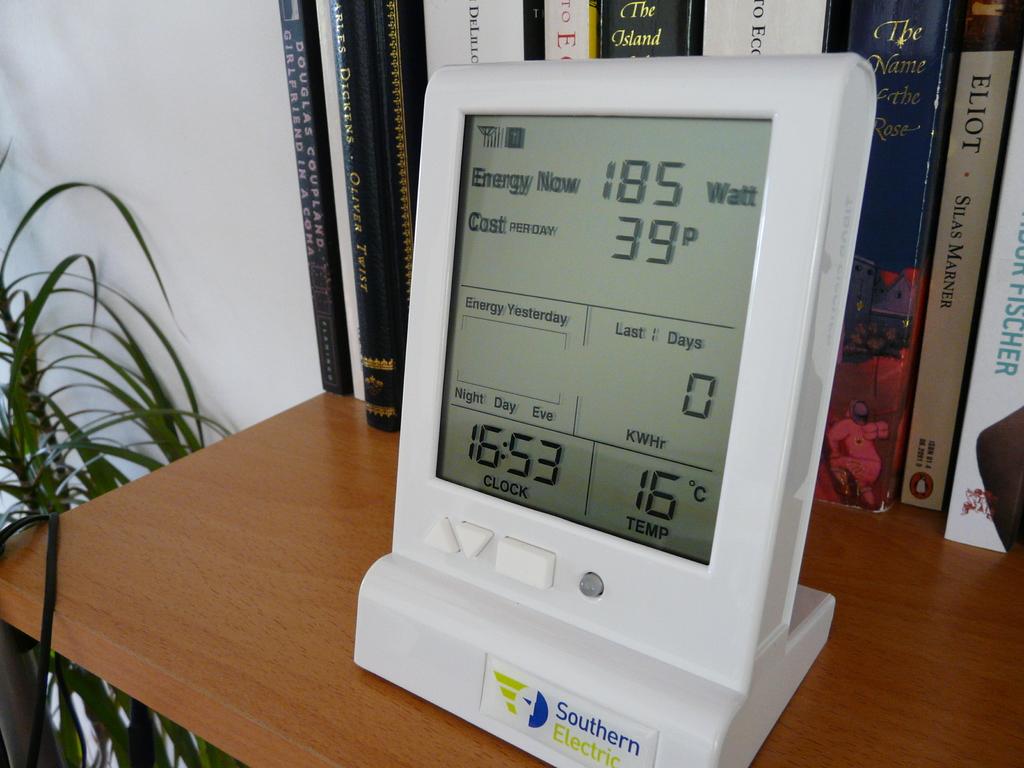This is paper?
Provide a succinct answer. Answering does not require reading text in the image. 